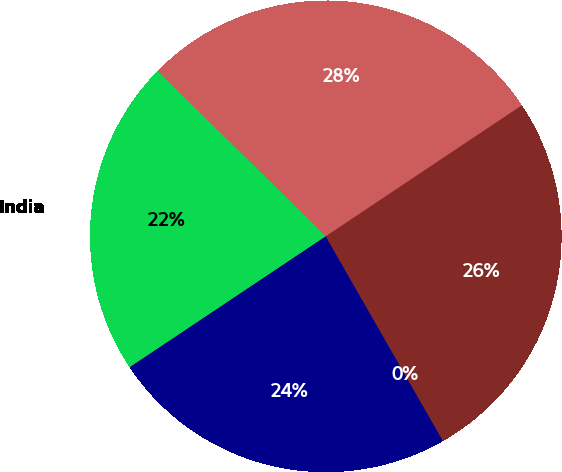Convert chart. <chart><loc_0><loc_0><loc_500><loc_500><pie_chart><fcel>United States<fcel>India<fcel>Japan<fcel>United Kingdom<fcel>Switzerland<nl><fcel>28.27%<fcel>21.73%<fcel>23.91%<fcel>0.0%<fcel>26.09%<nl></chart> 